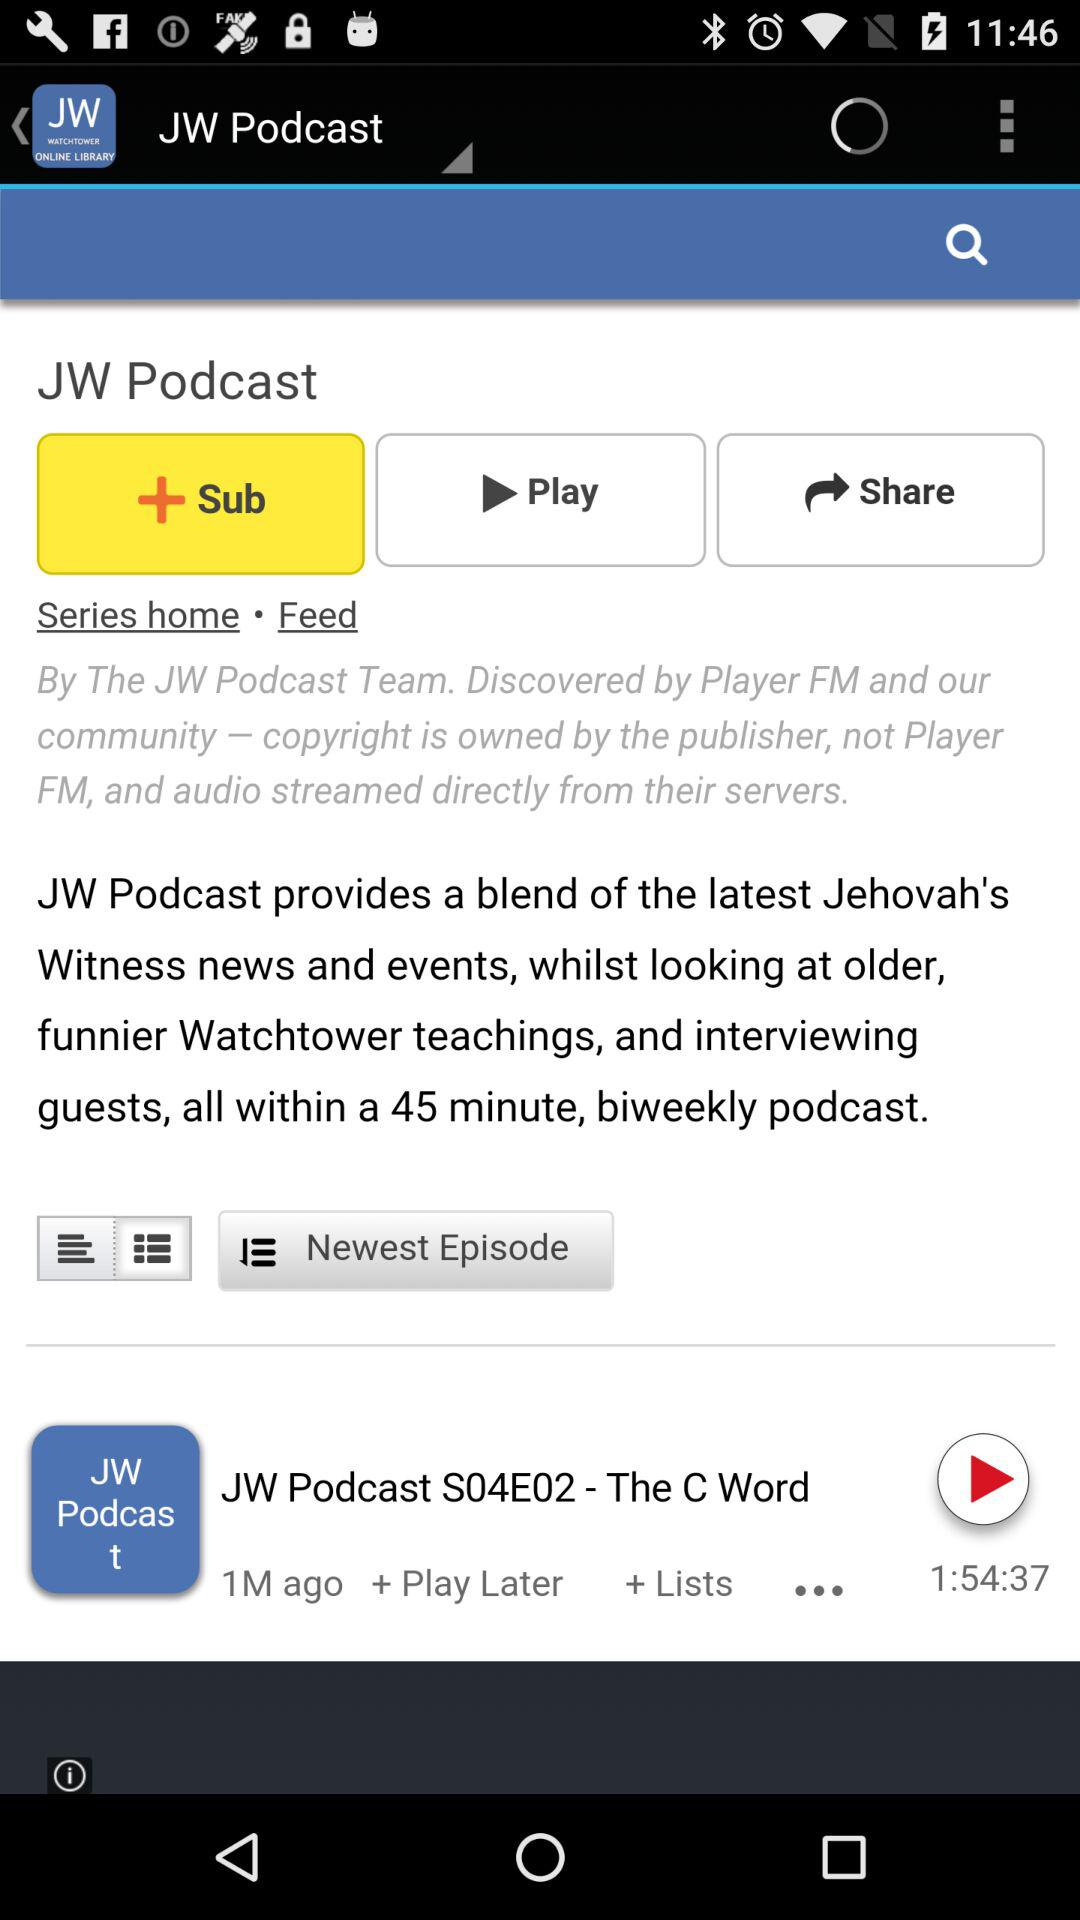What is the application name? The application name is "JW Podcast". 